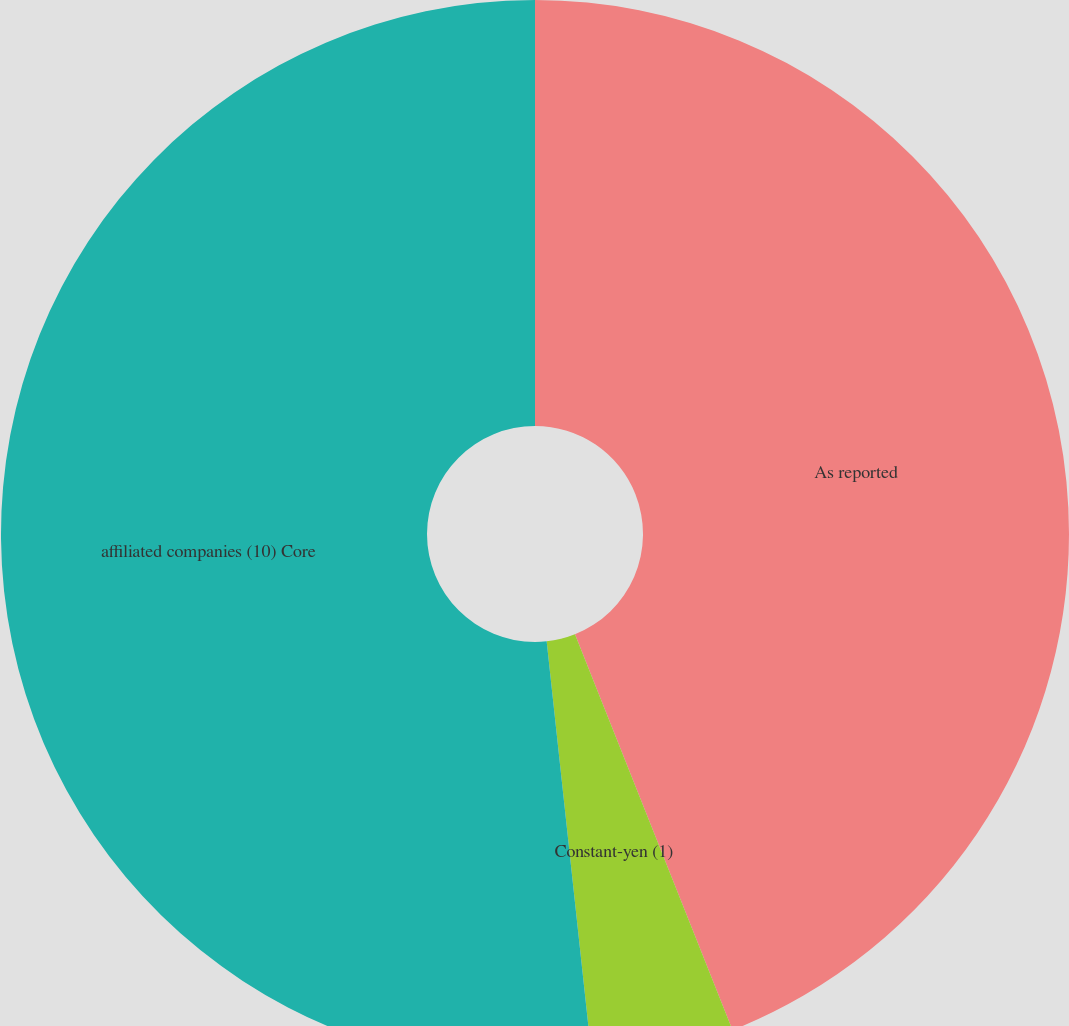Convert chart to OTSL. <chart><loc_0><loc_0><loc_500><loc_500><pie_chart><fcel>As reported<fcel>Constant-yen (1)<fcel>affiliated companies (10) Core<nl><fcel>43.97%<fcel>4.31%<fcel>51.72%<nl></chart> 